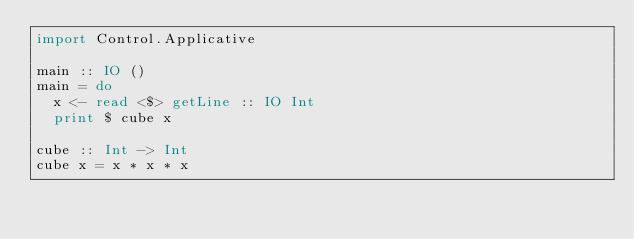<code> <loc_0><loc_0><loc_500><loc_500><_Haskell_>import Control.Applicative

main :: IO ()
main = do
  x <- read <$> getLine :: IO Int
  print $ cube x

cube :: Int -> Int
cube x = x * x * x</code> 